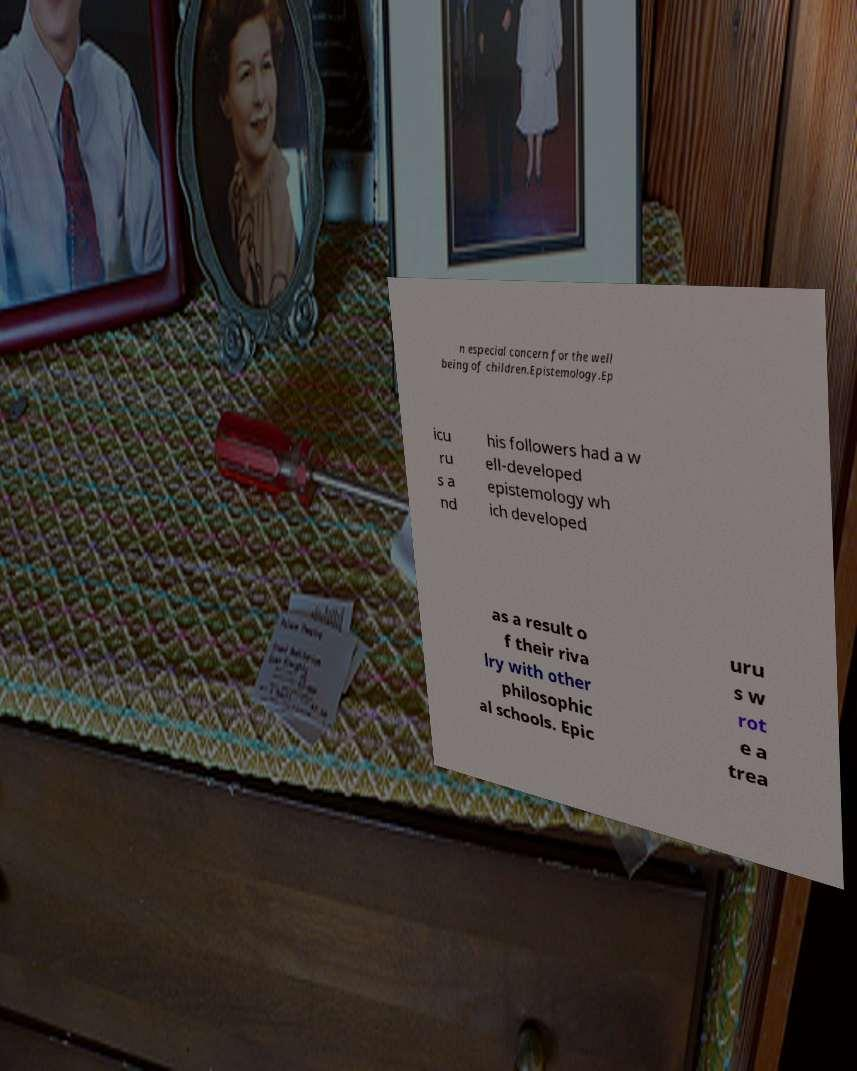Can you accurately transcribe the text from the provided image for me? n especial concern for the well being of children.Epistemology.Ep icu ru s a nd his followers had a w ell-developed epistemology wh ich developed as a result o f their riva lry with other philosophic al schools. Epic uru s w rot e a trea 